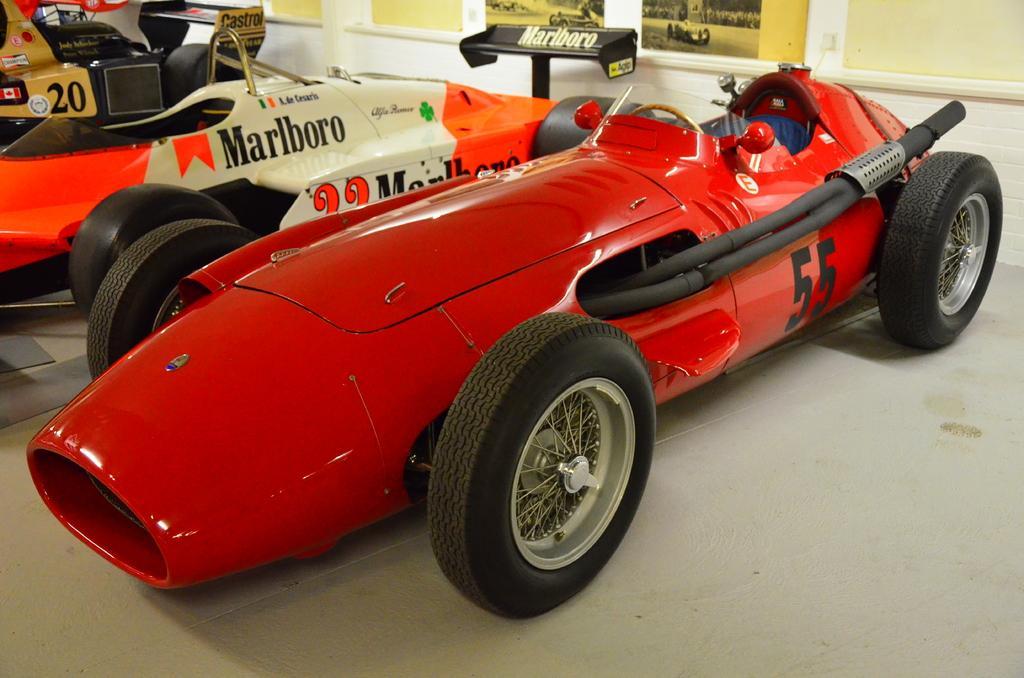Please provide a concise description of this image. In this image in the center there are some vehicles, and in the background there is a wall. On the wall there are some posters and there is some object, and at the bottom there is a floor. 